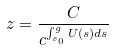<formula> <loc_0><loc_0><loc_500><loc_500>z = \frac { C } { c ^ { \int _ { s _ { 0 } } ^ { g } U ( s ) d s } }</formula> 